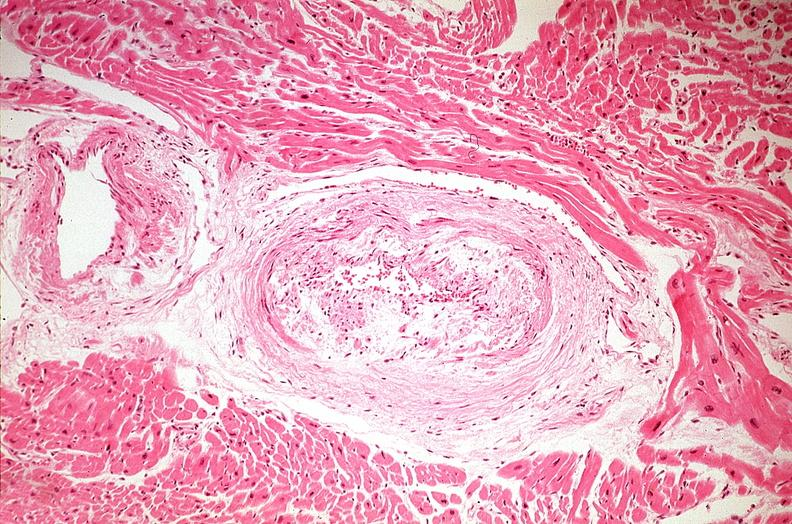does this image show heart, myocardial infarction, wavey fiber change, necrtosis, hemorrhage, and dissection?
Answer the question using a single word or phrase. Yes 